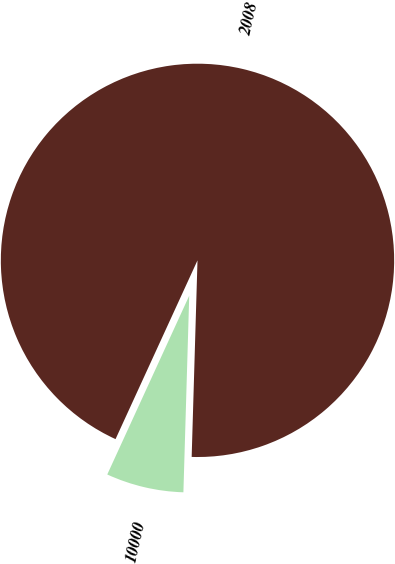Convert chart to OTSL. <chart><loc_0><loc_0><loc_500><loc_500><pie_chart><fcel>2008<fcel>10000<nl><fcel>93.63%<fcel>6.37%<nl></chart> 